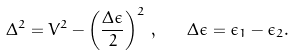Convert formula to latex. <formula><loc_0><loc_0><loc_500><loc_500>\Delta ^ { 2 } = V ^ { 2 } - \left ( \frac { \Delta \epsilon } { 2 } \right ) ^ { 2 } \, , \quad \Delta \epsilon = \epsilon _ { 1 } - \epsilon _ { 2 } .</formula> 